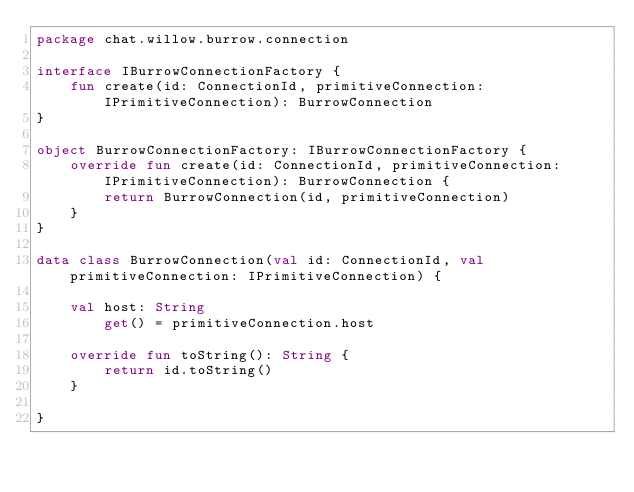<code> <loc_0><loc_0><loc_500><loc_500><_Kotlin_>package chat.willow.burrow.connection

interface IBurrowConnectionFactory {
    fun create(id: ConnectionId, primitiveConnection: IPrimitiveConnection): BurrowConnection
}

object BurrowConnectionFactory: IBurrowConnectionFactory {
    override fun create(id: ConnectionId, primitiveConnection: IPrimitiveConnection): BurrowConnection {
        return BurrowConnection(id, primitiveConnection)
    }
}

data class BurrowConnection(val id: ConnectionId, val primitiveConnection: IPrimitiveConnection) {

    val host: String
        get() = primitiveConnection.host

    override fun toString(): String {
        return id.toString()
    }

}</code> 